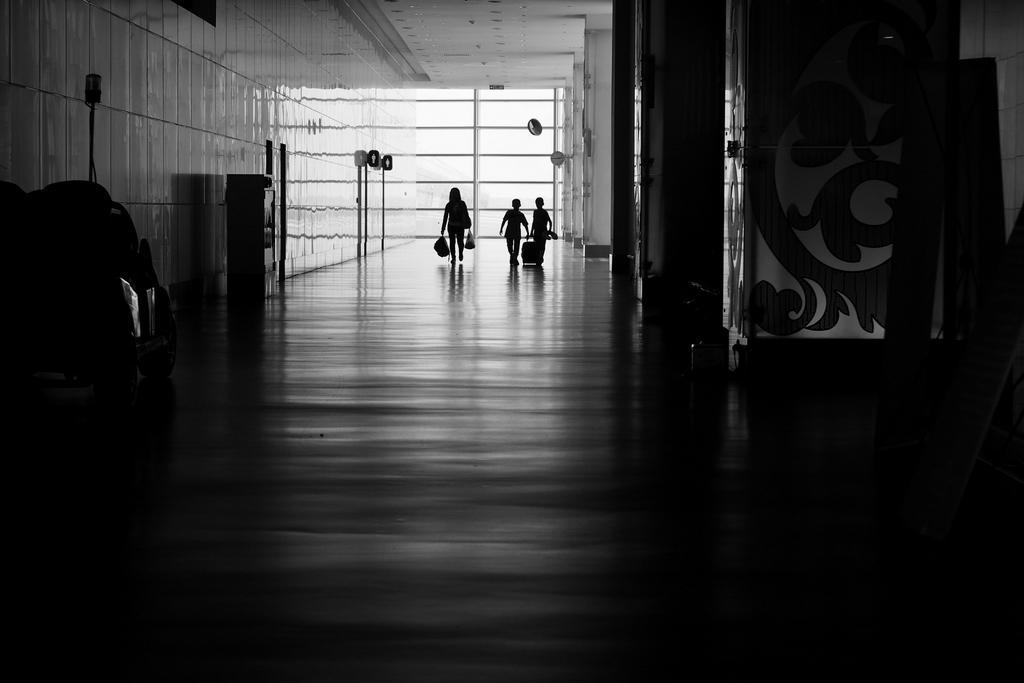Could you give a brief overview of what you see in this image? There are three persons holding an object in their hands and there is an object in the right and left corners. 